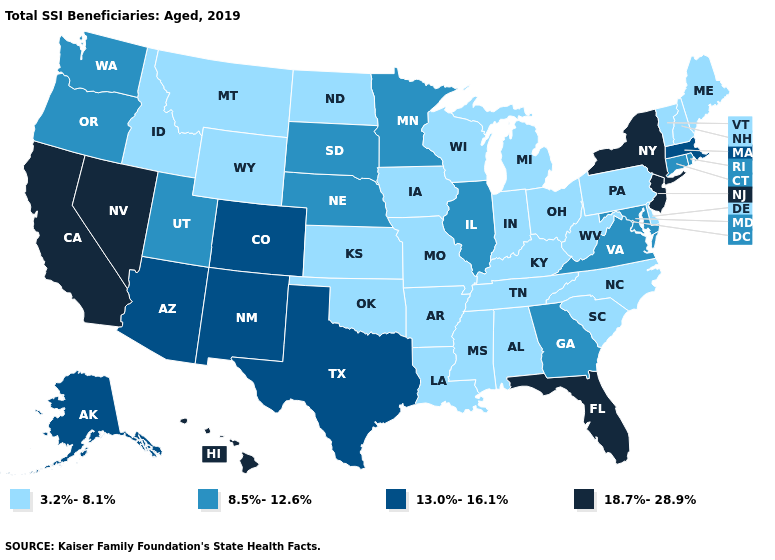Does the first symbol in the legend represent the smallest category?
Answer briefly. Yes. What is the value of Arizona?
Be succinct. 13.0%-16.1%. Name the states that have a value in the range 8.5%-12.6%?
Be succinct. Connecticut, Georgia, Illinois, Maryland, Minnesota, Nebraska, Oregon, Rhode Island, South Dakota, Utah, Virginia, Washington. What is the value of Oklahoma?
Write a very short answer. 3.2%-8.1%. What is the highest value in states that border South Dakota?
Keep it brief. 8.5%-12.6%. Among the states that border Delaware , which have the lowest value?
Write a very short answer. Pennsylvania. What is the value of West Virginia?
Give a very brief answer. 3.2%-8.1%. Is the legend a continuous bar?
Quick response, please. No. What is the value of North Dakota?
Keep it brief. 3.2%-8.1%. Does Oklahoma have the lowest value in the South?
Answer briefly. Yes. What is the highest value in the MidWest ?
Write a very short answer. 8.5%-12.6%. Which states have the lowest value in the West?
Short answer required. Idaho, Montana, Wyoming. What is the value of Florida?
Be succinct. 18.7%-28.9%. Does the first symbol in the legend represent the smallest category?
Keep it brief. Yes. Is the legend a continuous bar?
Answer briefly. No. 